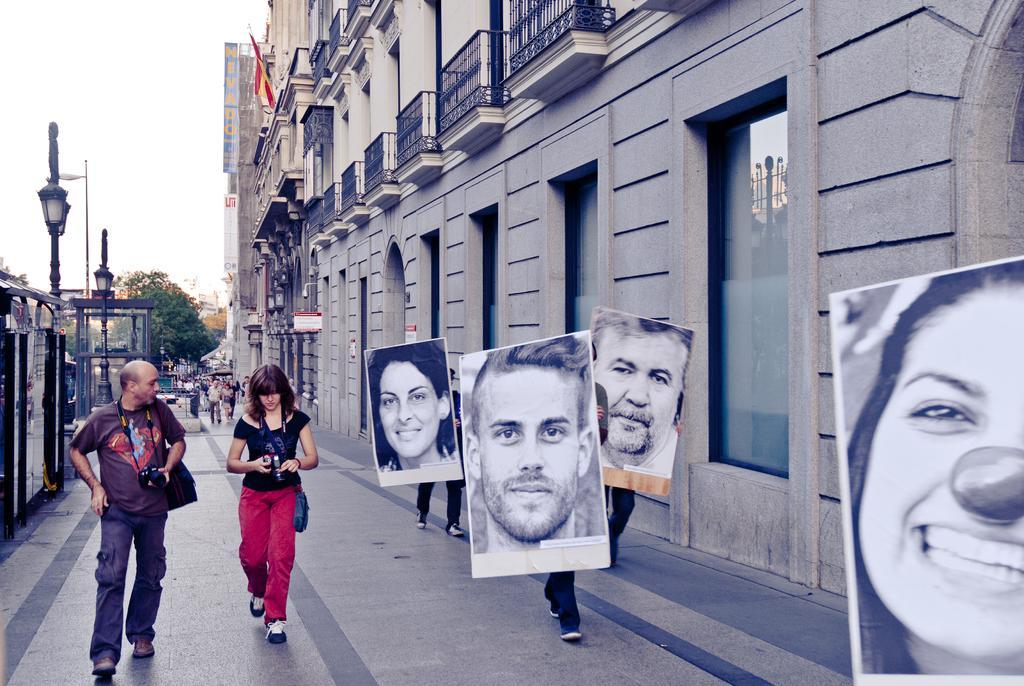In one or two sentences, can you explain what this image depicts? In this image two persons holding cameras and bags are walking. Also there are few people holding posters are walking. On the posters there are images of people. On the right side there is a building with windows and balconies. On the left side there are light poles. In the back there are few people, trees and sky. 